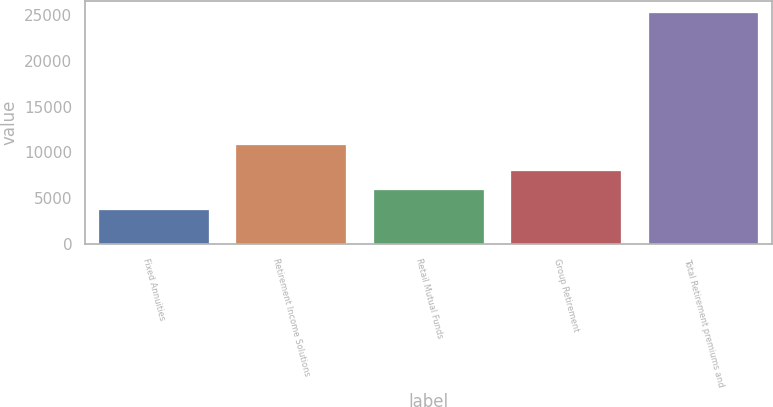Convert chart. <chart><loc_0><loc_0><loc_500><loc_500><bar_chart><fcel>Fixed Annuities<fcel>Retirement Income Solutions<fcel>Retail Mutual Funds<fcel>Group Retirement<fcel>Total Retirement premiums and<nl><fcel>3702<fcel>10828<fcel>5855.9<fcel>8009.8<fcel>25241<nl></chart> 